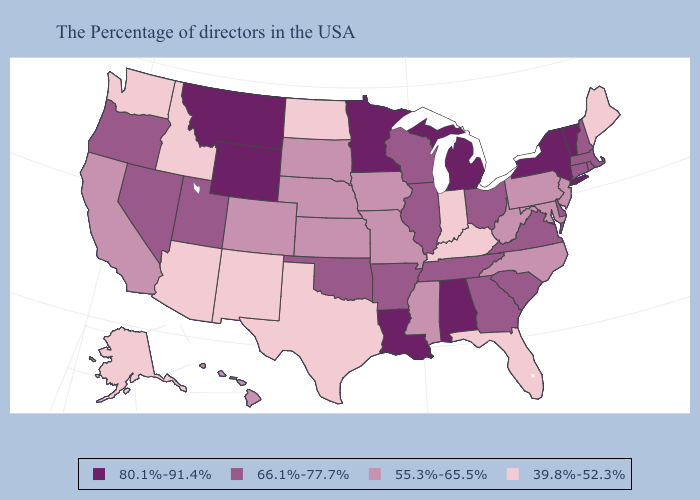Does Virginia have the lowest value in the USA?
Be succinct. No. Which states have the lowest value in the Northeast?
Short answer required. Maine. Does Idaho have the same value as Colorado?
Answer briefly. No. Name the states that have a value in the range 66.1%-77.7%?
Concise answer only. Massachusetts, Rhode Island, New Hampshire, Connecticut, Delaware, Virginia, South Carolina, Ohio, Georgia, Tennessee, Wisconsin, Illinois, Arkansas, Oklahoma, Utah, Nevada, Oregon. Does Utah have a higher value than Nevada?
Short answer required. No. What is the lowest value in the USA?
Short answer required. 39.8%-52.3%. What is the highest value in states that border Vermont?
Answer briefly. 80.1%-91.4%. What is the value of Arkansas?
Quick response, please. 66.1%-77.7%. Does North Dakota have the same value as Delaware?
Write a very short answer. No. How many symbols are there in the legend?
Answer briefly. 4. Among the states that border Colorado , which have the highest value?
Give a very brief answer. Wyoming. What is the value of Alabama?
Concise answer only. 80.1%-91.4%. What is the highest value in states that border North Dakota?
Be succinct. 80.1%-91.4%. What is the highest value in the MidWest ?
Short answer required. 80.1%-91.4%. Among the states that border Kentucky , does Indiana have the lowest value?
Short answer required. Yes. 